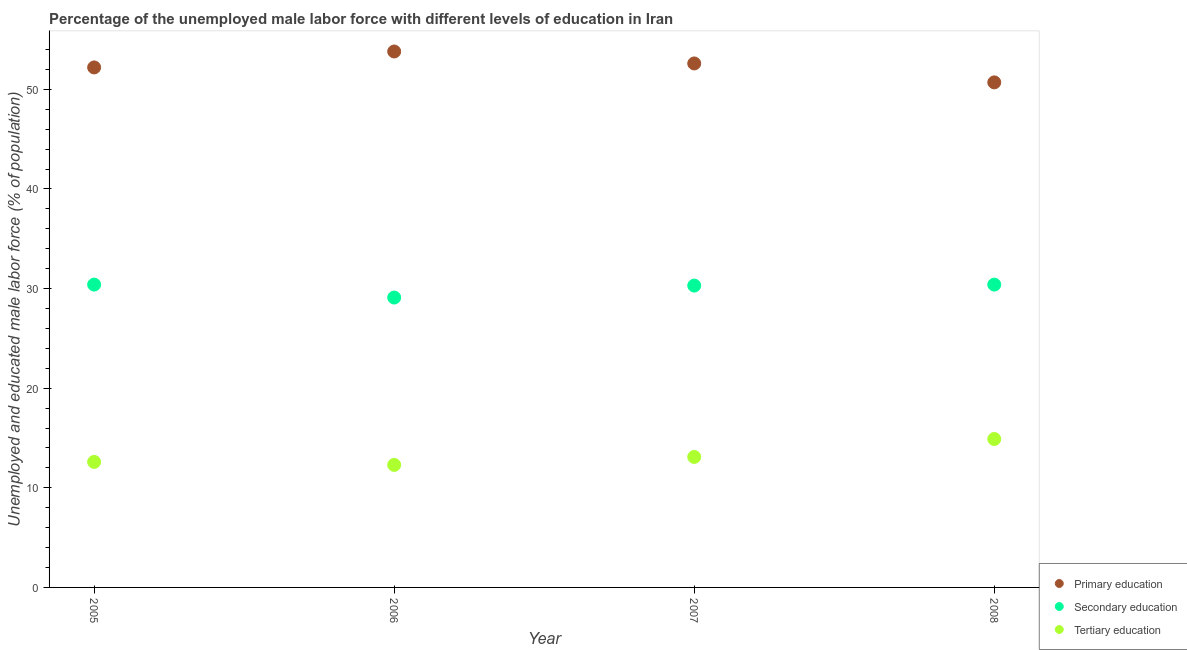How many different coloured dotlines are there?
Provide a short and direct response. 3. Is the number of dotlines equal to the number of legend labels?
Provide a short and direct response. Yes. What is the percentage of male labor force who received tertiary education in 2008?
Give a very brief answer. 14.9. Across all years, what is the maximum percentage of male labor force who received secondary education?
Your response must be concise. 30.4. Across all years, what is the minimum percentage of male labor force who received primary education?
Offer a very short reply. 50.7. In which year was the percentage of male labor force who received tertiary education maximum?
Offer a terse response. 2008. What is the total percentage of male labor force who received secondary education in the graph?
Provide a short and direct response. 120.2. What is the difference between the percentage of male labor force who received tertiary education in 2005 and that in 2008?
Ensure brevity in your answer.  -2.3. What is the difference between the percentage of male labor force who received secondary education in 2007 and the percentage of male labor force who received primary education in 2008?
Keep it short and to the point. -20.4. What is the average percentage of male labor force who received primary education per year?
Keep it short and to the point. 52.32. In the year 2006, what is the difference between the percentage of male labor force who received tertiary education and percentage of male labor force who received secondary education?
Keep it short and to the point. -16.8. What is the ratio of the percentage of male labor force who received primary education in 2005 to that in 2007?
Make the answer very short. 0.99. Is the difference between the percentage of male labor force who received tertiary education in 2006 and 2007 greater than the difference between the percentage of male labor force who received primary education in 2006 and 2007?
Ensure brevity in your answer.  No. What is the difference between the highest and the second highest percentage of male labor force who received tertiary education?
Offer a terse response. 1.8. What is the difference between the highest and the lowest percentage of male labor force who received secondary education?
Your response must be concise. 1.3. Is the sum of the percentage of male labor force who received secondary education in 2005 and 2008 greater than the maximum percentage of male labor force who received primary education across all years?
Offer a very short reply. Yes. Is it the case that in every year, the sum of the percentage of male labor force who received primary education and percentage of male labor force who received secondary education is greater than the percentage of male labor force who received tertiary education?
Give a very brief answer. Yes. Is the percentage of male labor force who received secondary education strictly less than the percentage of male labor force who received tertiary education over the years?
Offer a terse response. No. How many dotlines are there?
Give a very brief answer. 3. What is the difference between two consecutive major ticks on the Y-axis?
Your answer should be very brief. 10. How many legend labels are there?
Your answer should be compact. 3. What is the title of the graph?
Your response must be concise. Percentage of the unemployed male labor force with different levels of education in Iran. What is the label or title of the X-axis?
Make the answer very short. Year. What is the label or title of the Y-axis?
Ensure brevity in your answer.  Unemployed and educated male labor force (% of population). What is the Unemployed and educated male labor force (% of population) of Primary education in 2005?
Ensure brevity in your answer.  52.2. What is the Unemployed and educated male labor force (% of population) of Secondary education in 2005?
Provide a short and direct response. 30.4. What is the Unemployed and educated male labor force (% of population) in Tertiary education in 2005?
Your answer should be compact. 12.6. What is the Unemployed and educated male labor force (% of population) in Primary education in 2006?
Provide a succinct answer. 53.8. What is the Unemployed and educated male labor force (% of population) of Secondary education in 2006?
Your answer should be very brief. 29.1. What is the Unemployed and educated male labor force (% of population) of Tertiary education in 2006?
Your response must be concise. 12.3. What is the Unemployed and educated male labor force (% of population) of Primary education in 2007?
Ensure brevity in your answer.  52.6. What is the Unemployed and educated male labor force (% of population) of Secondary education in 2007?
Offer a very short reply. 30.3. What is the Unemployed and educated male labor force (% of population) in Tertiary education in 2007?
Your answer should be compact. 13.1. What is the Unemployed and educated male labor force (% of population) in Primary education in 2008?
Provide a succinct answer. 50.7. What is the Unemployed and educated male labor force (% of population) of Secondary education in 2008?
Keep it short and to the point. 30.4. What is the Unemployed and educated male labor force (% of population) in Tertiary education in 2008?
Keep it short and to the point. 14.9. Across all years, what is the maximum Unemployed and educated male labor force (% of population) in Primary education?
Your response must be concise. 53.8. Across all years, what is the maximum Unemployed and educated male labor force (% of population) of Secondary education?
Keep it short and to the point. 30.4. Across all years, what is the maximum Unemployed and educated male labor force (% of population) of Tertiary education?
Keep it short and to the point. 14.9. Across all years, what is the minimum Unemployed and educated male labor force (% of population) of Primary education?
Keep it short and to the point. 50.7. Across all years, what is the minimum Unemployed and educated male labor force (% of population) in Secondary education?
Provide a short and direct response. 29.1. Across all years, what is the minimum Unemployed and educated male labor force (% of population) of Tertiary education?
Make the answer very short. 12.3. What is the total Unemployed and educated male labor force (% of population) in Primary education in the graph?
Your answer should be very brief. 209.3. What is the total Unemployed and educated male labor force (% of population) of Secondary education in the graph?
Keep it short and to the point. 120.2. What is the total Unemployed and educated male labor force (% of population) in Tertiary education in the graph?
Your response must be concise. 52.9. What is the difference between the Unemployed and educated male labor force (% of population) of Secondary education in 2005 and that in 2006?
Offer a very short reply. 1.3. What is the difference between the Unemployed and educated male labor force (% of population) in Primary education in 2005 and that in 2007?
Your response must be concise. -0.4. What is the difference between the Unemployed and educated male labor force (% of population) of Secondary education in 2005 and that in 2007?
Offer a very short reply. 0.1. What is the difference between the Unemployed and educated male labor force (% of population) of Tertiary education in 2005 and that in 2007?
Offer a terse response. -0.5. What is the difference between the Unemployed and educated male labor force (% of population) in Primary education in 2005 and that in 2008?
Make the answer very short. 1.5. What is the difference between the Unemployed and educated male labor force (% of population) of Secondary education in 2005 and that in 2008?
Offer a terse response. 0. What is the difference between the Unemployed and educated male labor force (% of population) of Primary education in 2006 and that in 2007?
Provide a succinct answer. 1.2. What is the difference between the Unemployed and educated male labor force (% of population) of Secondary education in 2006 and that in 2007?
Provide a succinct answer. -1.2. What is the difference between the Unemployed and educated male labor force (% of population) of Tertiary education in 2006 and that in 2007?
Your response must be concise. -0.8. What is the difference between the Unemployed and educated male labor force (% of population) in Secondary education in 2006 and that in 2008?
Your response must be concise. -1.3. What is the difference between the Unemployed and educated male labor force (% of population) in Secondary education in 2007 and that in 2008?
Offer a terse response. -0.1. What is the difference between the Unemployed and educated male labor force (% of population) of Primary education in 2005 and the Unemployed and educated male labor force (% of population) of Secondary education in 2006?
Give a very brief answer. 23.1. What is the difference between the Unemployed and educated male labor force (% of population) of Primary education in 2005 and the Unemployed and educated male labor force (% of population) of Tertiary education in 2006?
Offer a terse response. 39.9. What is the difference between the Unemployed and educated male labor force (% of population) in Secondary education in 2005 and the Unemployed and educated male labor force (% of population) in Tertiary education in 2006?
Keep it short and to the point. 18.1. What is the difference between the Unemployed and educated male labor force (% of population) of Primary education in 2005 and the Unemployed and educated male labor force (% of population) of Secondary education in 2007?
Provide a succinct answer. 21.9. What is the difference between the Unemployed and educated male labor force (% of population) of Primary education in 2005 and the Unemployed and educated male labor force (% of population) of Tertiary education in 2007?
Keep it short and to the point. 39.1. What is the difference between the Unemployed and educated male labor force (% of population) in Secondary education in 2005 and the Unemployed and educated male labor force (% of population) in Tertiary education in 2007?
Your response must be concise. 17.3. What is the difference between the Unemployed and educated male labor force (% of population) in Primary education in 2005 and the Unemployed and educated male labor force (% of population) in Secondary education in 2008?
Provide a short and direct response. 21.8. What is the difference between the Unemployed and educated male labor force (% of population) of Primary education in 2005 and the Unemployed and educated male labor force (% of population) of Tertiary education in 2008?
Your answer should be compact. 37.3. What is the difference between the Unemployed and educated male labor force (% of population) of Secondary education in 2005 and the Unemployed and educated male labor force (% of population) of Tertiary education in 2008?
Provide a succinct answer. 15.5. What is the difference between the Unemployed and educated male labor force (% of population) in Primary education in 2006 and the Unemployed and educated male labor force (% of population) in Secondary education in 2007?
Ensure brevity in your answer.  23.5. What is the difference between the Unemployed and educated male labor force (% of population) in Primary education in 2006 and the Unemployed and educated male labor force (% of population) in Tertiary education in 2007?
Offer a very short reply. 40.7. What is the difference between the Unemployed and educated male labor force (% of population) of Secondary education in 2006 and the Unemployed and educated male labor force (% of population) of Tertiary education in 2007?
Your answer should be very brief. 16. What is the difference between the Unemployed and educated male labor force (% of population) in Primary education in 2006 and the Unemployed and educated male labor force (% of population) in Secondary education in 2008?
Provide a short and direct response. 23.4. What is the difference between the Unemployed and educated male labor force (% of population) of Primary education in 2006 and the Unemployed and educated male labor force (% of population) of Tertiary education in 2008?
Your response must be concise. 38.9. What is the difference between the Unemployed and educated male labor force (% of population) in Primary education in 2007 and the Unemployed and educated male labor force (% of population) in Tertiary education in 2008?
Make the answer very short. 37.7. What is the difference between the Unemployed and educated male labor force (% of population) of Secondary education in 2007 and the Unemployed and educated male labor force (% of population) of Tertiary education in 2008?
Offer a terse response. 15.4. What is the average Unemployed and educated male labor force (% of population) of Primary education per year?
Your answer should be very brief. 52.33. What is the average Unemployed and educated male labor force (% of population) in Secondary education per year?
Keep it short and to the point. 30.05. What is the average Unemployed and educated male labor force (% of population) in Tertiary education per year?
Keep it short and to the point. 13.22. In the year 2005, what is the difference between the Unemployed and educated male labor force (% of population) in Primary education and Unemployed and educated male labor force (% of population) in Secondary education?
Offer a terse response. 21.8. In the year 2005, what is the difference between the Unemployed and educated male labor force (% of population) in Primary education and Unemployed and educated male labor force (% of population) in Tertiary education?
Offer a terse response. 39.6. In the year 2006, what is the difference between the Unemployed and educated male labor force (% of population) in Primary education and Unemployed and educated male labor force (% of population) in Secondary education?
Give a very brief answer. 24.7. In the year 2006, what is the difference between the Unemployed and educated male labor force (% of population) in Primary education and Unemployed and educated male labor force (% of population) in Tertiary education?
Keep it short and to the point. 41.5. In the year 2006, what is the difference between the Unemployed and educated male labor force (% of population) in Secondary education and Unemployed and educated male labor force (% of population) in Tertiary education?
Offer a very short reply. 16.8. In the year 2007, what is the difference between the Unemployed and educated male labor force (% of population) of Primary education and Unemployed and educated male labor force (% of population) of Secondary education?
Provide a succinct answer. 22.3. In the year 2007, what is the difference between the Unemployed and educated male labor force (% of population) in Primary education and Unemployed and educated male labor force (% of population) in Tertiary education?
Offer a very short reply. 39.5. In the year 2007, what is the difference between the Unemployed and educated male labor force (% of population) of Secondary education and Unemployed and educated male labor force (% of population) of Tertiary education?
Your answer should be very brief. 17.2. In the year 2008, what is the difference between the Unemployed and educated male labor force (% of population) of Primary education and Unemployed and educated male labor force (% of population) of Secondary education?
Provide a succinct answer. 20.3. In the year 2008, what is the difference between the Unemployed and educated male labor force (% of population) in Primary education and Unemployed and educated male labor force (% of population) in Tertiary education?
Offer a terse response. 35.8. What is the ratio of the Unemployed and educated male labor force (% of population) in Primary education in 2005 to that in 2006?
Ensure brevity in your answer.  0.97. What is the ratio of the Unemployed and educated male labor force (% of population) in Secondary education in 2005 to that in 2006?
Offer a terse response. 1.04. What is the ratio of the Unemployed and educated male labor force (% of population) of Tertiary education in 2005 to that in 2006?
Your answer should be very brief. 1.02. What is the ratio of the Unemployed and educated male labor force (% of population) of Secondary education in 2005 to that in 2007?
Your response must be concise. 1. What is the ratio of the Unemployed and educated male labor force (% of population) of Tertiary education in 2005 to that in 2007?
Your response must be concise. 0.96. What is the ratio of the Unemployed and educated male labor force (% of population) in Primary education in 2005 to that in 2008?
Give a very brief answer. 1.03. What is the ratio of the Unemployed and educated male labor force (% of population) of Tertiary education in 2005 to that in 2008?
Ensure brevity in your answer.  0.85. What is the ratio of the Unemployed and educated male labor force (% of population) of Primary education in 2006 to that in 2007?
Provide a short and direct response. 1.02. What is the ratio of the Unemployed and educated male labor force (% of population) in Secondary education in 2006 to that in 2007?
Offer a terse response. 0.96. What is the ratio of the Unemployed and educated male labor force (% of population) of Tertiary education in 2006 to that in 2007?
Give a very brief answer. 0.94. What is the ratio of the Unemployed and educated male labor force (% of population) of Primary education in 2006 to that in 2008?
Provide a succinct answer. 1.06. What is the ratio of the Unemployed and educated male labor force (% of population) of Secondary education in 2006 to that in 2008?
Your answer should be very brief. 0.96. What is the ratio of the Unemployed and educated male labor force (% of population) in Tertiary education in 2006 to that in 2008?
Offer a terse response. 0.83. What is the ratio of the Unemployed and educated male labor force (% of population) in Primary education in 2007 to that in 2008?
Provide a succinct answer. 1.04. What is the ratio of the Unemployed and educated male labor force (% of population) in Secondary education in 2007 to that in 2008?
Provide a short and direct response. 1. What is the ratio of the Unemployed and educated male labor force (% of population) of Tertiary education in 2007 to that in 2008?
Ensure brevity in your answer.  0.88. What is the difference between the highest and the second highest Unemployed and educated male labor force (% of population) in Primary education?
Provide a succinct answer. 1.2. What is the difference between the highest and the second highest Unemployed and educated male labor force (% of population) in Secondary education?
Keep it short and to the point. 0. What is the difference between the highest and the lowest Unemployed and educated male labor force (% of population) in Primary education?
Ensure brevity in your answer.  3.1. What is the difference between the highest and the lowest Unemployed and educated male labor force (% of population) of Secondary education?
Give a very brief answer. 1.3. 